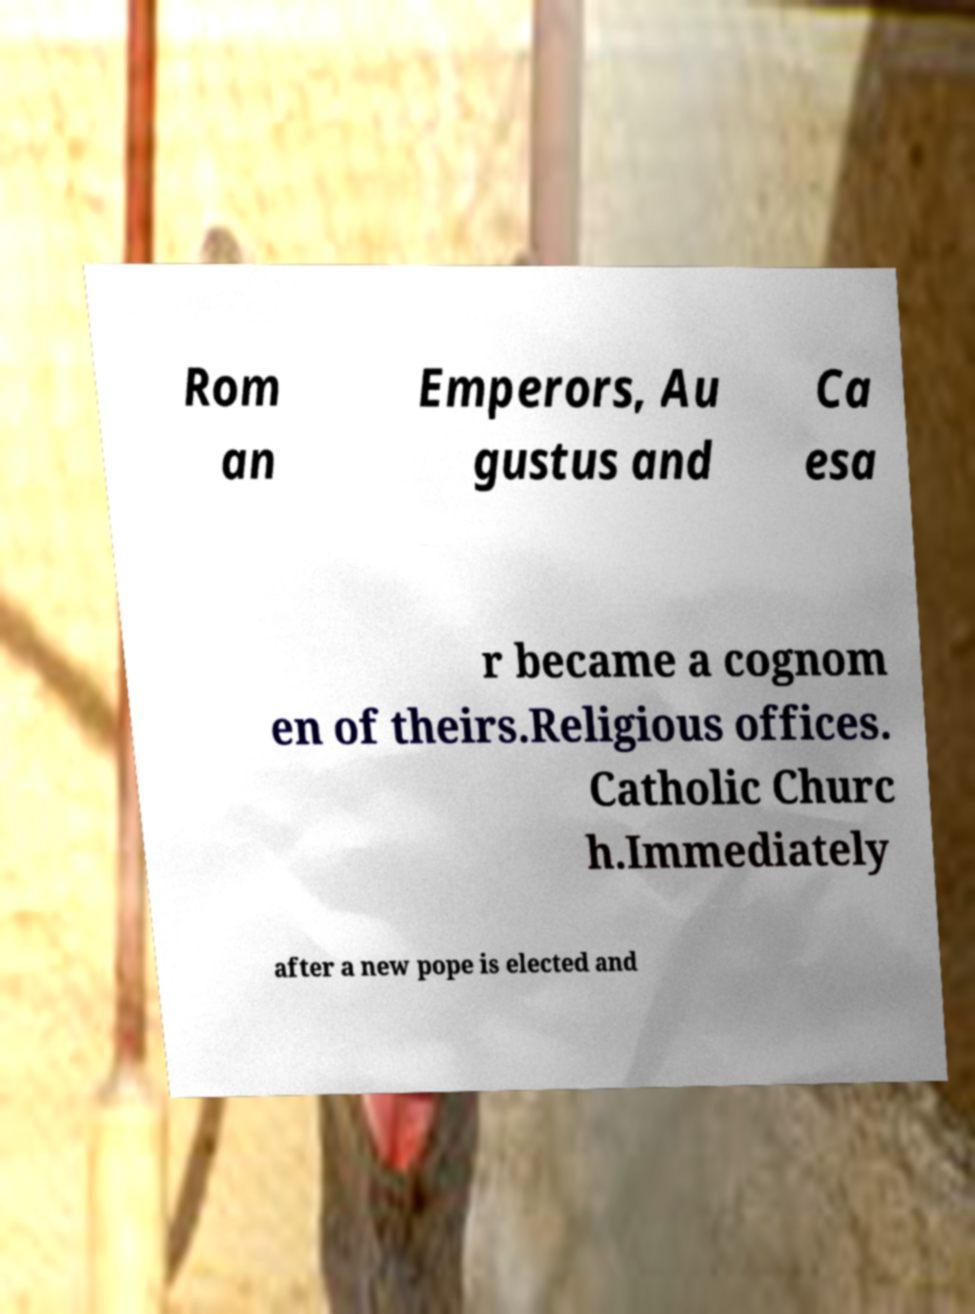Can you read and provide the text displayed in the image?This photo seems to have some interesting text. Can you extract and type it out for me? Rom an Emperors, Au gustus and Ca esa r became a cognom en of theirs.Religious offices. Catholic Churc h.Immediately after a new pope is elected and 